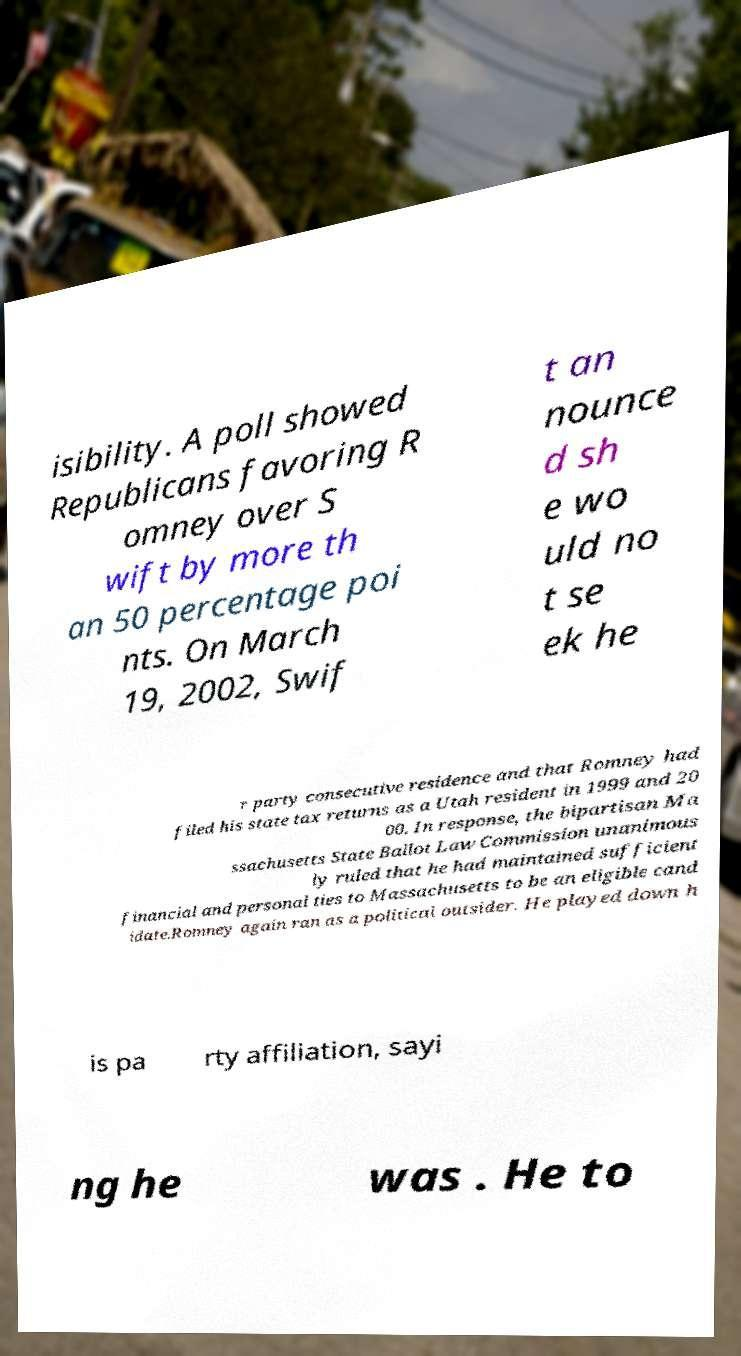Could you assist in decoding the text presented in this image and type it out clearly? isibility. A poll showed Republicans favoring R omney over S wift by more th an 50 percentage poi nts. On March 19, 2002, Swif t an nounce d sh e wo uld no t se ek he r party consecutive residence and that Romney had filed his state tax returns as a Utah resident in 1999 and 20 00. In response, the bipartisan Ma ssachusetts State Ballot Law Commission unanimous ly ruled that he had maintained sufficient financial and personal ties to Massachusetts to be an eligible cand idate.Romney again ran as a political outsider. He played down h is pa rty affiliation, sayi ng he was . He to 